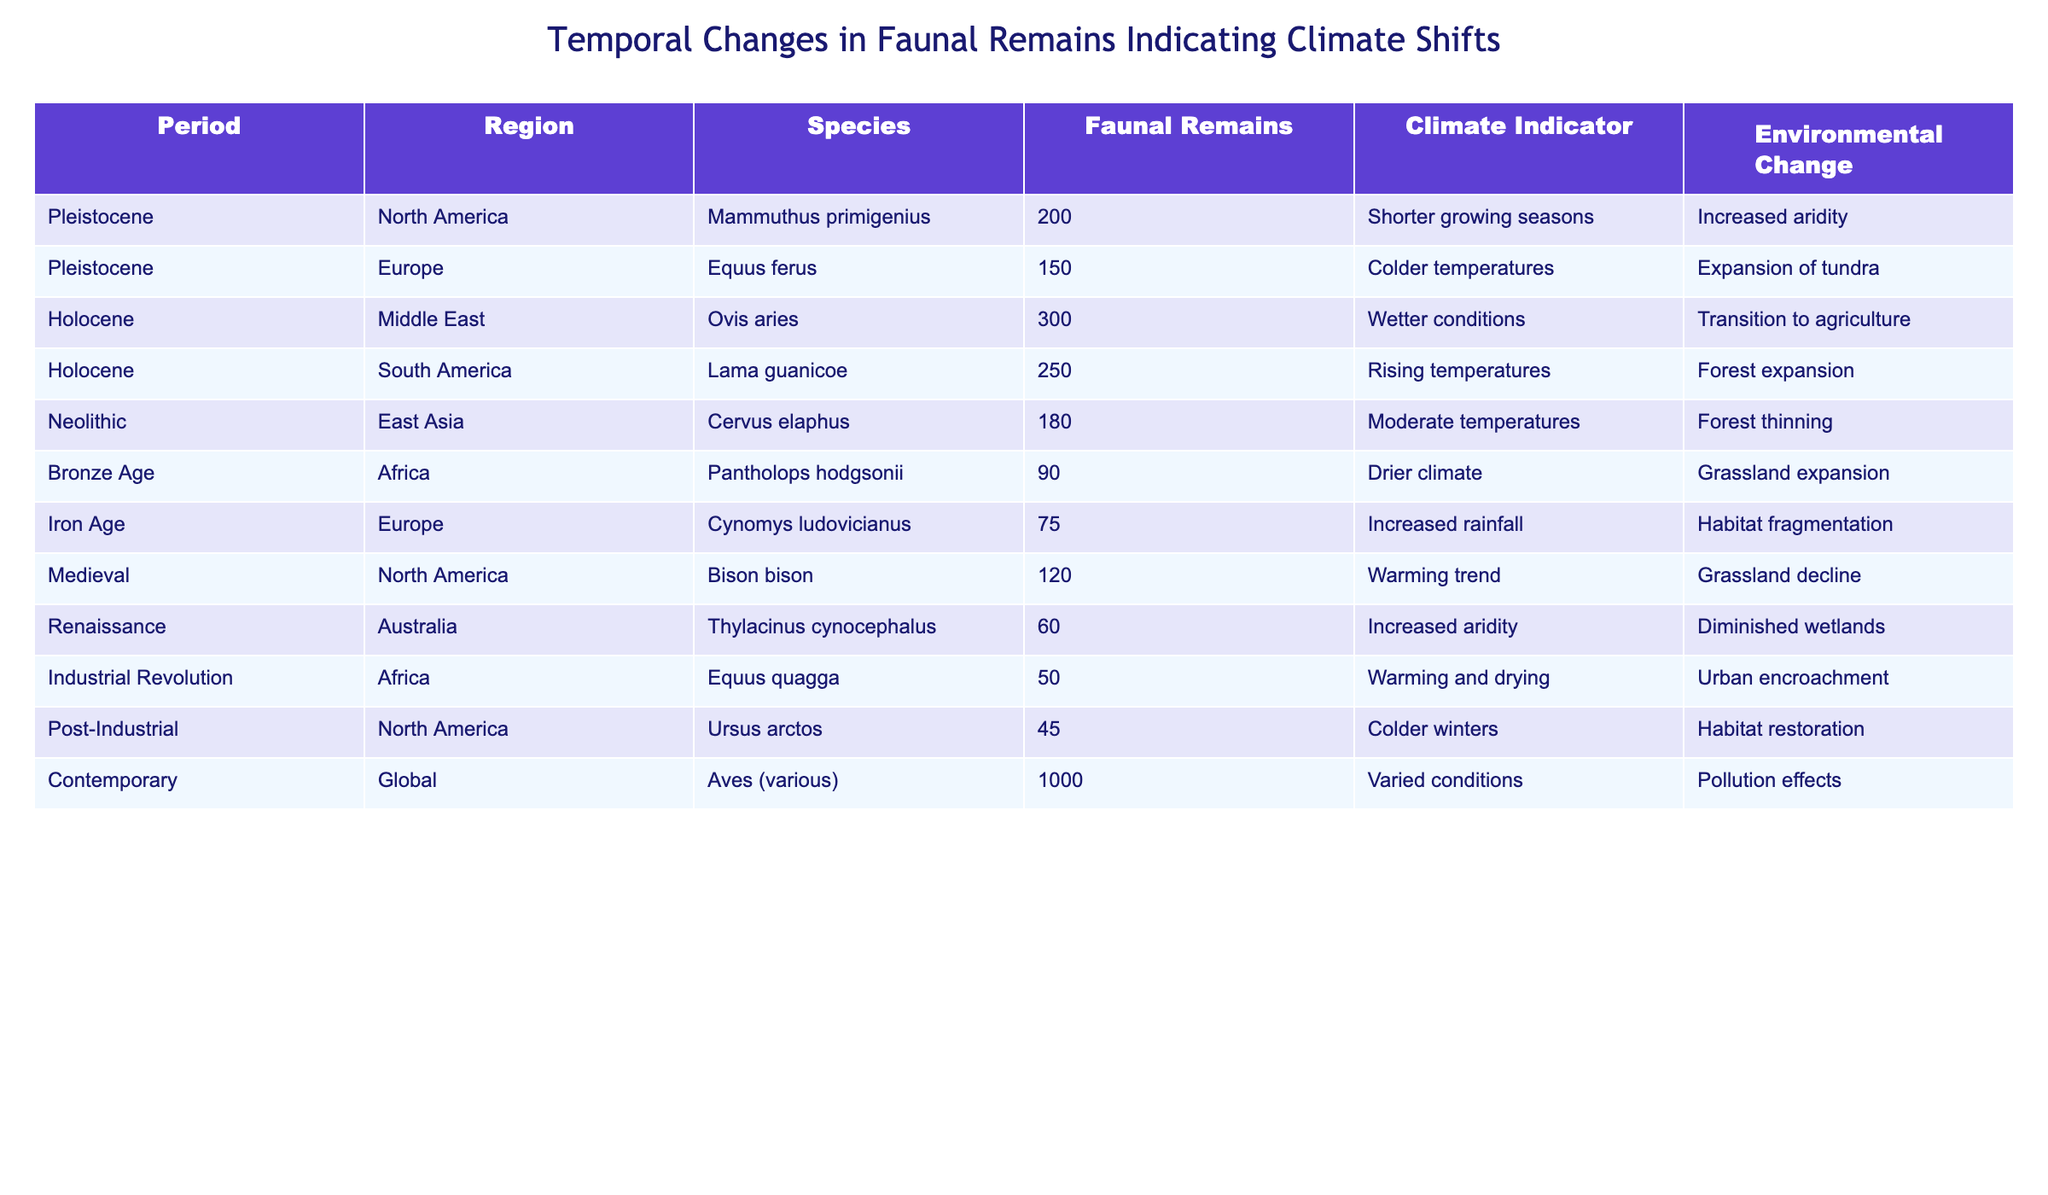What species had the highest number of faunal remains? By examining the "Faunal Remains" column in the table, we can see that "Aves (various)" in the Contemporary period has the highest value at 1000.
Answer: Aves (various) Which climate indicator is associated with the Bronze Age in Africa? The "Climate Indicator" column shows that for the Bronze Age in Africa, the associated climate indicator is "Drier climate."
Answer: Drier climate What is the total number of faunal remains recorded in the Holocene period? To find the total, we add up the values from the "Faunal Remains" column for the Holocene entries: 300 (Ovis aries) + 250 (Lama guanicoe) = 550.
Answer: 550 True or False: The Iron Age in Europe shows increased rainfall as a climate indicator. Referring to the "Climate Indicator" column for the Iron Age in Europe, it states "Increased rainfall," making the statement true.
Answer: True How does the number of faunal remains in the Renaissance compare to the number in the Medieval period? The Renaissance has 60 faunal remains (Thylacinus cynocephalus) and the Medieval period has 120 (Bison bison). Therefore, 120 - 60 = 60, indicating the Medieval period has 60 more remains.
Answer: 60 more Which regions experienced environmental changes linked to grassland expansion, and what were the species found there? By examining the table, both the Bronze Age in Africa (Pantholops hodgsonii) and the Pleistocene in North America (Mammuthus primigenius) relate to grassland expansion.
Answer: Africa: Pantholops hodgsonii; North America: Mammuthus primigenius What was the average number of faunal remains across the Pleistocene and Holocene periods? For Pleistocene: 200 (Mammuthus primigenius) + 150 (Equus ferus) = 350. For Holocene: 300 (Ovis aries) + 250 (Lama guanicoe) = 550. The average of these totals is (350 + 550) / 4 = 225.
Answer: 225 Identify the period with the lowest number of faunal remains and state its value. Looking through the "Faunal Remains" column, the lowest value is 45 from the Post-Industrial period (Ursus arctos).
Answer: 45 What trend in climate is shown during the Medieval period in North America compared to the Renaissance in Australia? The Medieval period shows a "Warming trend" while the Renaissance shows "Increased aridity." Thus, the Medieval period indicates a temperature increase, and the Renaissance indicates a shift towards arid conditions.
Answer: Warming trend vs. Increased aridity How many more faunal remains were found in the Holocene than in the Iron Age? The Holocene has 550 faunal remains (300 + 250), while the Iron Age has 75. The difference is 550 - 75 = 475.
Answer: 475 more Which species in the table indicates a transition towards agriculture and how many faunal remains were identified? "Ovis aries" in the Holocene period has 300 faunal remains noted for indicating a transition to agriculture.
Answer: Ovis aries, 300 faunal remains 